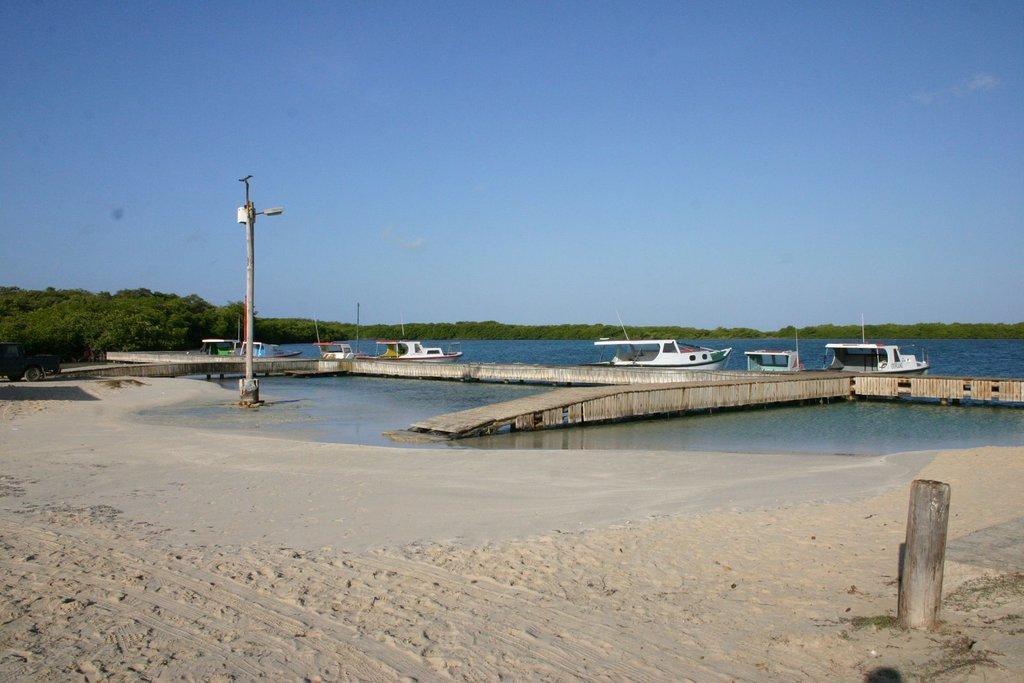In one or two sentences, can you explain what this image depicts? In front of the image there is a sand. There is a wooden pole. There is a lamp post. There are boats in the water. Behind the boats there is a wooden platform. In the background of the image there are trees. At the top of the image there is sky. 